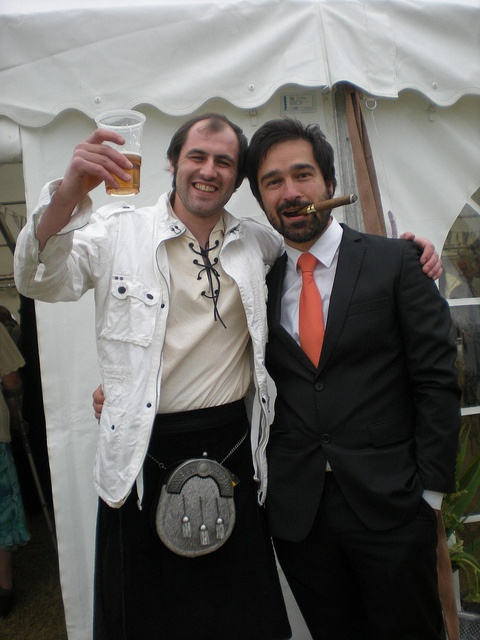Describe the objects in this image and their specific colors. I can see people in lavender, black, darkgray, lightgray, and gray tones, people in lavender, black, brown, darkgray, and gray tones, people in lavender and black tones, cup in lavender, darkgray, lightgray, brown, and gray tones, and tie in lavender, brown, and red tones in this image. 